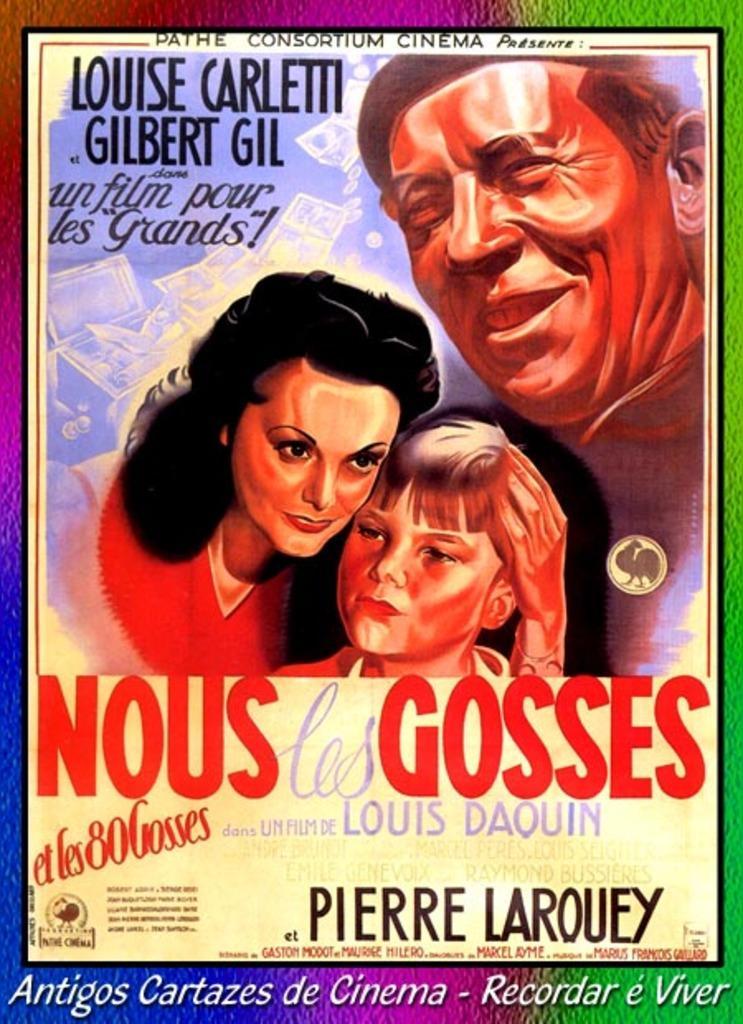Could you give a brief overview of what you see in this image? In this image we can see a graphical image of three persons. One woman is holding a boy with her hand. 